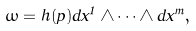<formula> <loc_0><loc_0><loc_500><loc_500>\omega = h ( p ) d x ^ { 1 } \wedge \cdots \wedge d x ^ { m } ,</formula> 